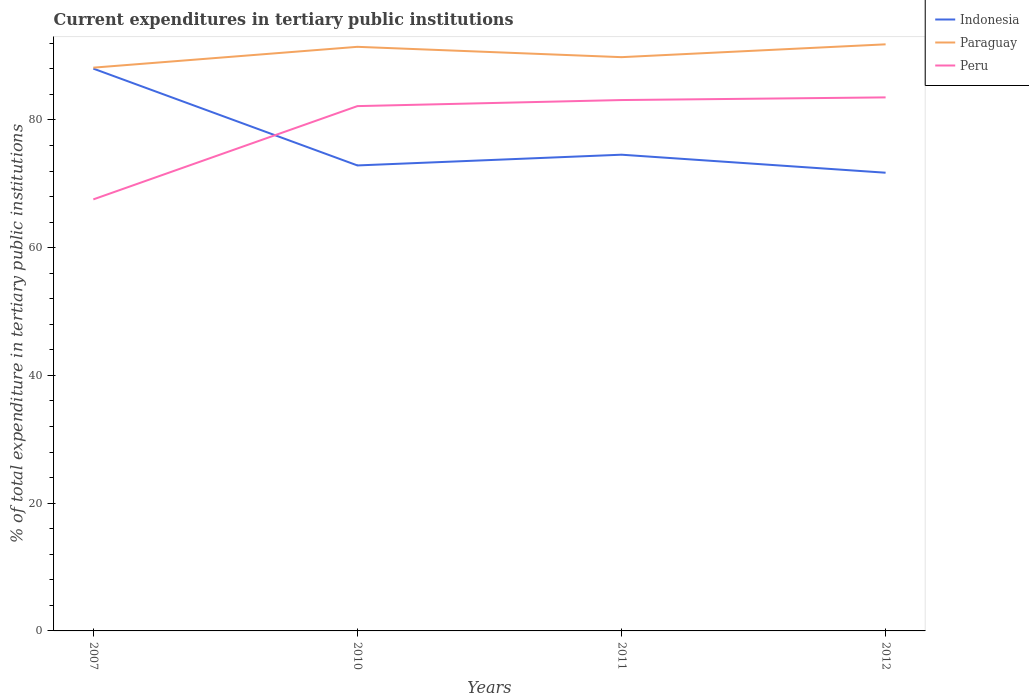How many different coloured lines are there?
Give a very brief answer. 3. Across all years, what is the maximum current expenditures in tertiary public institutions in Peru?
Make the answer very short. 67.57. What is the total current expenditures in tertiary public institutions in Paraguay in the graph?
Your answer should be very brief. -0.39. What is the difference between the highest and the second highest current expenditures in tertiary public institutions in Peru?
Your response must be concise. 15.97. Is the current expenditures in tertiary public institutions in Indonesia strictly greater than the current expenditures in tertiary public institutions in Paraguay over the years?
Your response must be concise. Yes. Are the values on the major ticks of Y-axis written in scientific E-notation?
Your answer should be very brief. No. Does the graph contain any zero values?
Provide a short and direct response. No. Where does the legend appear in the graph?
Provide a short and direct response. Top right. What is the title of the graph?
Give a very brief answer. Current expenditures in tertiary public institutions. What is the label or title of the X-axis?
Keep it short and to the point. Years. What is the label or title of the Y-axis?
Provide a short and direct response. % of total expenditure in tertiary public institutions. What is the % of total expenditure in tertiary public institutions of Indonesia in 2007?
Provide a succinct answer. 88.04. What is the % of total expenditure in tertiary public institutions of Paraguay in 2007?
Offer a terse response. 88.19. What is the % of total expenditure in tertiary public institutions of Peru in 2007?
Ensure brevity in your answer.  67.57. What is the % of total expenditure in tertiary public institutions in Indonesia in 2010?
Provide a short and direct response. 72.88. What is the % of total expenditure in tertiary public institutions in Paraguay in 2010?
Offer a terse response. 91.45. What is the % of total expenditure in tertiary public institutions in Peru in 2010?
Offer a very short reply. 82.17. What is the % of total expenditure in tertiary public institutions in Indonesia in 2011?
Keep it short and to the point. 74.56. What is the % of total expenditure in tertiary public institutions of Paraguay in 2011?
Provide a short and direct response. 89.84. What is the % of total expenditure in tertiary public institutions in Peru in 2011?
Keep it short and to the point. 83.12. What is the % of total expenditure in tertiary public institutions in Indonesia in 2012?
Ensure brevity in your answer.  71.74. What is the % of total expenditure in tertiary public institutions of Paraguay in 2012?
Your answer should be compact. 91.85. What is the % of total expenditure in tertiary public institutions of Peru in 2012?
Offer a very short reply. 83.54. Across all years, what is the maximum % of total expenditure in tertiary public institutions of Indonesia?
Your response must be concise. 88.04. Across all years, what is the maximum % of total expenditure in tertiary public institutions of Paraguay?
Ensure brevity in your answer.  91.85. Across all years, what is the maximum % of total expenditure in tertiary public institutions of Peru?
Provide a succinct answer. 83.54. Across all years, what is the minimum % of total expenditure in tertiary public institutions in Indonesia?
Your answer should be very brief. 71.74. Across all years, what is the minimum % of total expenditure in tertiary public institutions of Paraguay?
Offer a very short reply. 88.19. Across all years, what is the minimum % of total expenditure in tertiary public institutions of Peru?
Provide a short and direct response. 67.57. What is the total % of total expenditure in tertiary public institutions of Indonesia in the graph?
Offer a terse response. 307.23. What is the total % of total expenditure in tertiary public institutions in Paraguay in the graph?
Offer a very short reply. 361.33. What is the total % of total expenditure in tertiary public institutions in Peru in the graph?
Your answer should be compact. 316.4. What is the difference between the % of total expenditure in tertiary public institutions in Indonesia in 2007 and that in 2010?
Keep it short and to the point. 15.16. What is the difference between the % of total expenditure in tertiary public institutions of Paraguay in 2007 and that in 2010?
Offer a very short reply. -3.26. What is the difference between the % of total expenditure in tertiary public institutions in Peru in 2007 and that in 2010?
Offer a terse response. -14.61. What is the difference between the % of total expenditure in tertiary public institutions in Indonesia in 2007 and that in 2011?
Your response must be concise. 13.48. What is the difference between the % of total expenditure in tertiary public institutions in Paraguay in 2007 and that in 2011?
Your answer should be compact. -1.64. What is the difference between the % of total expenditure in tertiary public institutions of Peru in 2007 and that in 2011?
Keep it short and to the point. -15.55. What is the difference between the % of total expenditure in tertiary public institutions in Indonesia in 2007 and that in 2012?
Your answer should be very brief. 16.3. What is the difference between the % of total expenditure in tertiary public institutions of Paraguay in 2007 and that in 2012?
Your response must be concise. -3.65. What is the difference between the % of total expenditure in tertiary public institutions of Peru in 2007 and that in 2012?
Offer a terse response. -15.97. What is the difference between the % of total expenditure in tertiary public institutions of Indonesia in 2010 and that in 2011?
Provide a short and direct response. -1.68. What is the difference between the % of total expenditure in tertiary public institutions of Paraguay in 2010 and that in 2011?
Provide a short and direct response. 1.62. What is the difference between the % of total expenditure in tertiary public institutions in Peru in 2010 and that in 2011?
Your response must be concise. -0.95. What is the difference between the % of total expenditure in tertiary public institutions of Indonesia in 2010 and that in 2012?
Your answer should be very brief. 1.14. What is the difference between the % of total expenditure in tertiary public institutions of Paraguay in 2010 and that in 2012?
Give a very brief answer. -0.39. What is the difference between the % of total expenditure in tertiary public institutions of Peru in 2010 and that in 2012?
Provide a succinct answer. -1.37. What is the difference between the % of total expenditure in tertiary public institutions in Indonesia in 2011 and that in 2012?
Provide a short and direct response. 2.82. What is the difference between the % of total expenditure in tertiary public institutions in Paraguay in 2011 and that in 2012?
Your answer should be compact. -2.01. What is the difference between the % of total expenditure in tertiary public institutions in Peru in 2011 and that in 2012?
Offer a very short reply. -0.42. What is the difference between the % of total expenditure in tertiary public institutions in Indonesia in 2007 and the % of total expenditure in tertiary public institutions in Paraguay in 2010?
Give a very brief answer. -3.41. What is the difference between the % of total expenditure in tertiary public institutions of Indonesia in 2007 and the % of total expenditure in tertiary public institutions of Peru in 2010?
Your response must be concise. 5.87. What is the difference between the % of total expenditure in tertiary public institutions in Paraguay in 2007 and the % of total expenditure in tertiary public institutions in Peru in 2010?
Provide a short and direct response. 6.02. What is the difference between the % of total expenditure in tertiary public institutions in Indonesia in 2007 and the % of total expenditure in tertiary public institutions in Paraguay in 2011?
Your answer should be compact. -1.79. What is the difference between the % of total expenditure in tertiary public institutions in Indonesia in 2007 and the % of total expenditure in tertiary public institutions in Peru in 2011?
Ensure brevity in your answer.  4.92. What is the difference between the % of total expenditure in tertiary public institutions in Paraguay in 2007 and the % of total expenditure in tertiary public institutions in Peru in 2011?
Offer a terse response. 5.07. What is the difference between the % of total expenditure in tertiary public institutions of Indonesia in 2007 and the % of total expenditure in tertiary public institutions of Paraguay in 2012?
Your response must be concise. -3.8. What is the difference between the % of total expenditure in tertiary public institutions in Indonesia in 2007 and the % of total expenditure in tertiary public institutions in Peru in 2012?
Your answer should be very brief. 4.51. What is the difference between the % of total expenditure in tertiary public institutions in Paraguay in 2007 and the % of total expenditure in tertiary public institutions in Peru in 2012?
Provide a succinct answer. 4.66. What is the difference between the % of total expenditure in tertiary public institutions in Indonesia in 2010 and the % of total expenditure in tertiary public institutions in Paraguay in 2011?
Give a very brief answer. -16.95. What is the difference between the % of total expenditure in tertiary public institutions in Indonesia in 2010 and the % of total expenditure in tertiary public institutions in Peru in 2011?
Provide a succinct answer. -10.24. What is the difference between the % of total expenditure in tertiary public institutions in Paraguay in 2010 and the % of total expenditure in tertiary public institutions in Peru in 2011?
Make the answer very short. 8.33. What is the difference between the % of total expenditure in tertiary public institutions of Indonesia in 2010 and the % of total expenditure in tertiary public institutions of Paraguay in 2012?
Give a very brief answer. -18.96. What is the difference between the % of total expenditure in tertiary public institutions in Indonesia in 2010 and the % of total expenditure in tertiary public institutions in Peru in 2012?
Ensure brevity in your answer.  -10.66. What is the difference between the % of total expenditure in tertiary public institutions in Paraguay in 2010 and the % of total expenditure in tertiary public institutions in Peru in 2012?
Keep it short and to the point. 7.92. What is the difference between the % of total expenditure in tertiary public institutions in Indonesia in 2011 and the % of total expenditure in tertiary public institutions in Paraguay in 2012?
Make the answer very short. -17.28. What is the difference between the % of total expenditure in tertiary public institutions in Indonesia in 2011 and the % of total expenditure in tertiary public institutions in Peru in 2012?
Give a very brief answer. -8.98. What is the difference between the % of total expenditure in tertiary public institutions of Paraguay in 2011 and the % of total expenditure in tertiary public institutions of Peru in 2012?
Make the answer very short. 6.3. What is the average % of total expenditure in tertiary public institutions of Indonesia per year?
Ensure brevity in your answer.  76.81. What is the average % of total expenditure in tertiary public institutions of Paraguay per year?
Ensure brevity in your answer.  90.33. What is the average % of total expenditure in tertiary public institutions of Peru per year?
Offer a very short reply. 79.1. In the year 2007, what is the difference between the % of total expenditure in tertiary public institutions of Indonesia and % of total expenditure in tertiary public institutions of Paraguay?
Your answer should be very brief. -0.15. In the year 2007, what is the difference between the % of total expenditure in tertiary public institutions in Indonesia and % of total expenditure in tertiary public institutions in Peru?
Give a very brief answer. 20.48. In the year 2007, what is the difference between the % of total expenditure in tertiary public institutions of Paraguay and % of total expenditure in tertiary public institutions of Peru?
Your response must be concise. 20.63. In the year 2010, what is the difference between the % of total expenditure in tertiary public institutions of Indonesia and % of total expenditure in tertiary public institutions of Paraguay?
Provide a short and direct response. -18.57. In the year 2010, what is the difference between the % of total expenditure in tertiary public institutions in Indonesia and % of total expenditure in tertiary public institutions in Peru?
Provide a succinct answer. -9.29. In the year 2010, what is the difference between the % of total expenditure in tertiary public institutions in Paraguay and % of total expenditure in tertiary public institutions in Peru?
Your response must be concise. 9.28. In the year 2011, what is the difference between the % of total expenditure in tertiary public institutions of Indonesia and % of total expenditure in tertiary public institutions of Paraguay?
Offer a very short reply. -15.27. In the year 2011, what is the difference between the % of total expenditure in tertiary public institutions in Indonesia and % of total expenditure in tertiary public institutions in Peru?
Offer a very short reply. -8.56. In the year 2011, what is the difference between the % of total expenditure in tertiary public institutions in Paraguay and % of total expenditure in tertiary public institutions in Peru?
Your response must be concise. 6.72. In the year 2012, what is the difference between the % of total expenditure in tertiary public institutions in Indonesia and % of total expenditure in tertiary public institutions in Paraguay?
Your answer should be very brief. -20.1. In the year 2012, what is the difference between the % of total expenditure in tertiary public institutions in Indonesia and % of total expenditure in tertiary public institutions in Peru?
Ensure brevity in your answer.  -11.8. In the year 2012, what is the difference between the % of total expenditure in tertiary public institutions of Paraguay and % of total expenditure in tertiary public institutions of Peru?
Your response must be concise. 8.31. What is the ratio of the % of total expenditure in tertiary public institutions in Indonesia in 2007 to that in 2010?
Provide a succinct answer. 1.21. What is the ratio of the % of total expenditure in tertiary public institutions of Peru in 2007 to that in 2010?
Offer a very short reply. 0.82. What is the ratio of the % of total expenditure in tertiary public institutions of Indonesia in 2007 to that in 2011?
Provide a succinct answer. 1.18. What is the ratio of the % of total expenditure in tertiary public institutions in Paraguay in 2007 to that in 2011?
Make the answer very short. 0.98. What is the ratio of the % of total expenditure in tertiary public institutions of Peru in 2007 to that in 2011?
Make the answer very short. 0.81. What is the ratio of the % of total expenditure in tertiary public institutions in Indonesia in 2007 to that in 2012?
Ensure brevity in your answer.  1.23. What is the ratio of the % of total expenditure in tertiary public institutions in Paraguay in 2007 to that in 2012?
Give a very brief answer. 0.96. What is the ratio of the % of total expenditure in tertiary public institutions in Peru in 2007 to that in 2012?
Make the answer very short. 0.81. What is the ratio of the % of total expenditure in tertiary public institutions in Indonesia in 2010 to that in 2011?
Provide a short and direct response. 0.98. What is the ratio of the % of total expenditure in tertiary public institutions in Peru in 2010 to that in 2011?
Provide a short and direct response. 0.99. What is the ratio of the % of total expenditure in tertiary public institutions of Indonesia in 2010 to that in 2012?
Provide a short and direct response. 1.02. What is the ratio of the % of total expenditure in tertiary public institutions in Peru in 2010 to that in 2012?
Provide a short and direct response. 0.98. What is the ratio of the % of total expenditure in tertiary public institutions of Indonesia in 2011 to that in 2012?
Ensure brevity in your answer.  1.04. What is the ratio of the % of total expenditure in tertiary public institutions in Paraguay in 2011 to that in 2012?
Offer a terse response. 0.98. What is the difference between the highest and the second highest % of total expenditure in tertiary public institutions in Indonesia?
Give a very brief answer. 13.48. What is the difference between the highest and the second highest % of total expenditure in tertiary public institutions in Paraguay?
Provide a short and direct response. 0.39. What is the difference between the highest and the second highest % of total expenditure in tertiary public institutions in Peru?
Offer a terse response. 0.42. What is the difference between the highest and the lowest % of total expenditure in tertiary public institutions in Indonesia?
Your response must be concise. 16.3. What is the difference between the highest and the lowest % of total expenditure in tertiary public institutions of Paraguay?
Ensure brevity in your answer.  3.65. What is the difference between the highest and the lowest % of total expenditure in tertiary public institutions of Peru?
Make the answer very short. 15.97. 